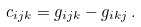<formula> <loc_0><loc_0><loc_500><loc_500>c _ { i j k } = g _ { i j k } - g _ { i k j } \, .</formula> 